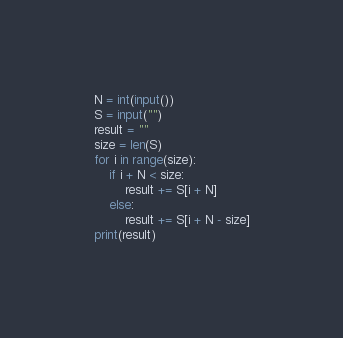Convert code to text. <code><loc_0><loc_0><loc_500><loc_500><_Python_>N = int(input())
S = input("")
result = ""
size = len(S)
for i in range(size):
    if i + N < size:
        result += S[i + N]
    else:
        result += S[i + N - size]
print(result)</code> 